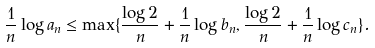Convert formula to latex. <formula><loc_0><loc_0><loc_500><loc_500>\frac { 1 } { n } \log a _ { n } \leq \max \{ \frac { \log 2 } { n } + \frac { 1 } { n } \log b _ { n } , \frac { \log 2 } { n } + \frac { 1 } { n } \log c _ { n } \} .</formula> 